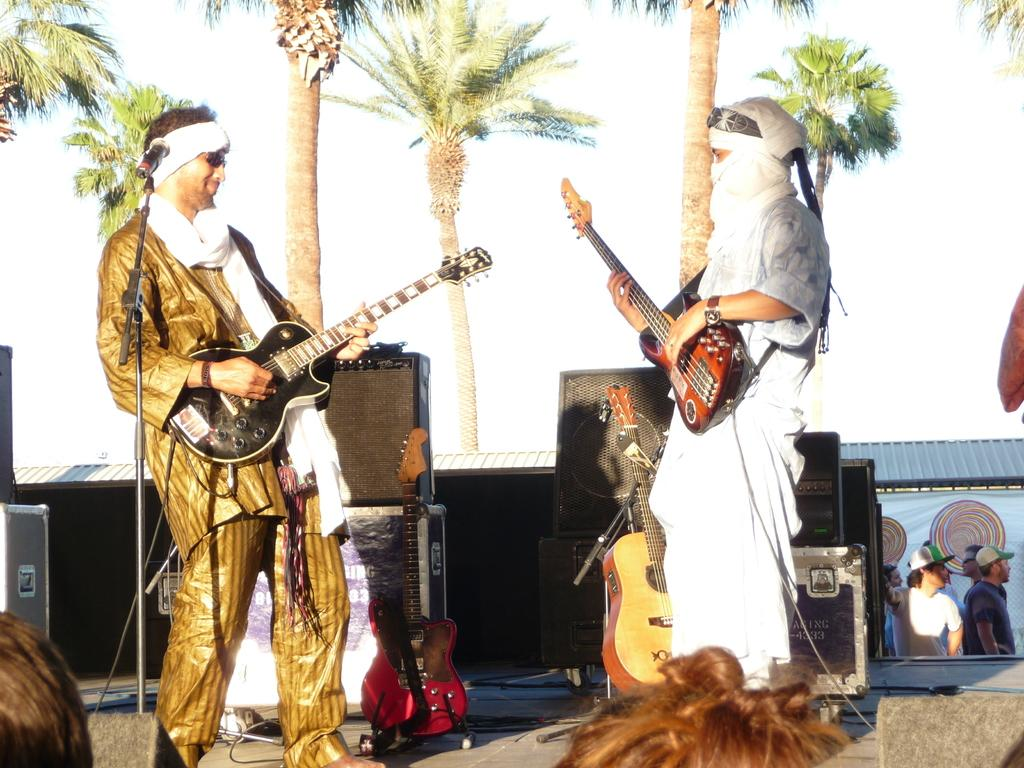How many people are in the image? There are two persons in the image. What are the persons doing in the image? The persons are standing and playing guitar. What can be seen in the background of the image? There are trees and the sky visible in the background of the image. What objects are present in the image related to music? There are musical instruments in the image. What type of force can be seen pushing the kitten in the image? There is no kitten present in the image, and therefore no force can be seen pushing it. How many hens are visible in the image? There are no hens present in the image. 